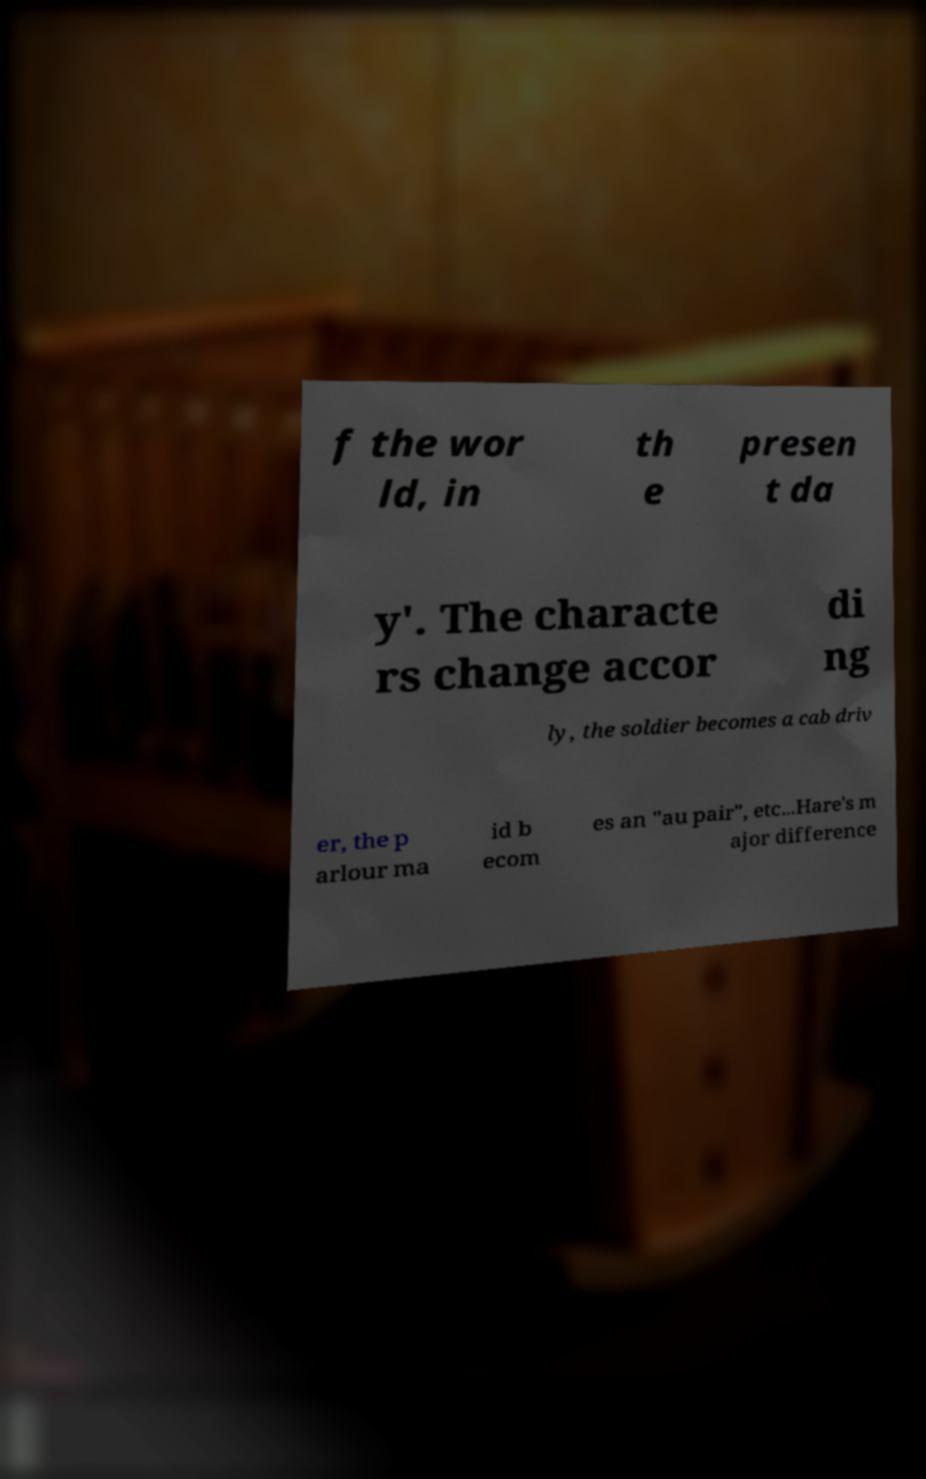For documentation purposes, I need the text within this image transcribed. Could you provide that? f the wor ld, in th e presen t da y'. The characte rs change accor di ng ly, the soldier becomes a cab driv er, the p arlour ma id b ecom es an "au pair", etc...Hare's m ajor difference 